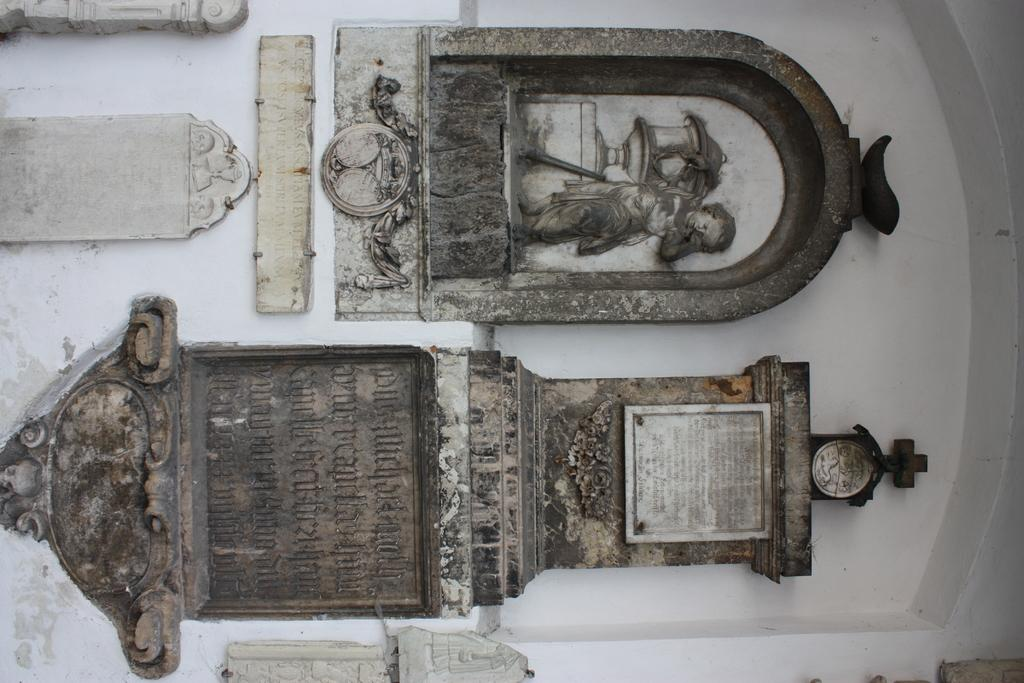What is the main subject of the image? The main subject of the image is a sculpture. Is there any text or label associated with the sculpture? Yes, there is a name stone on the wall in the image. What is the beginner's level of interest in the sculpture's purpose? There is no information about a beginner's level of interest or the sculpture's purpose in the image. 